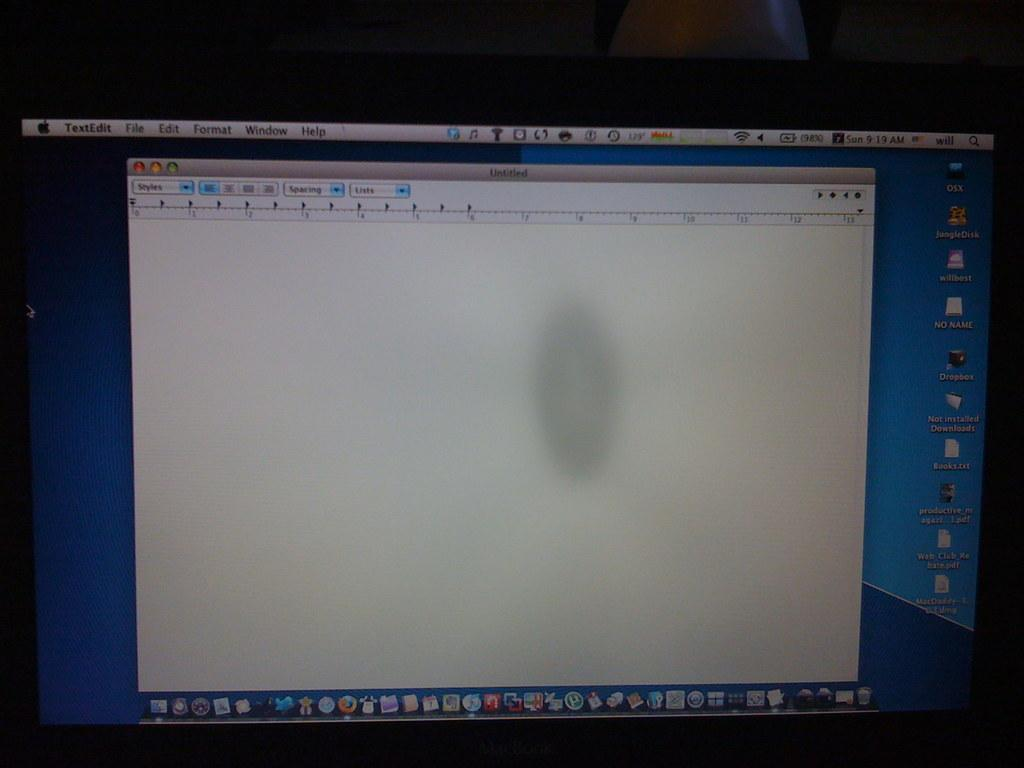<image>
Offer a succinct explanation of the picture presented. A dim photo of a mac monitor showing a blank text edit document at 9:19 am. 